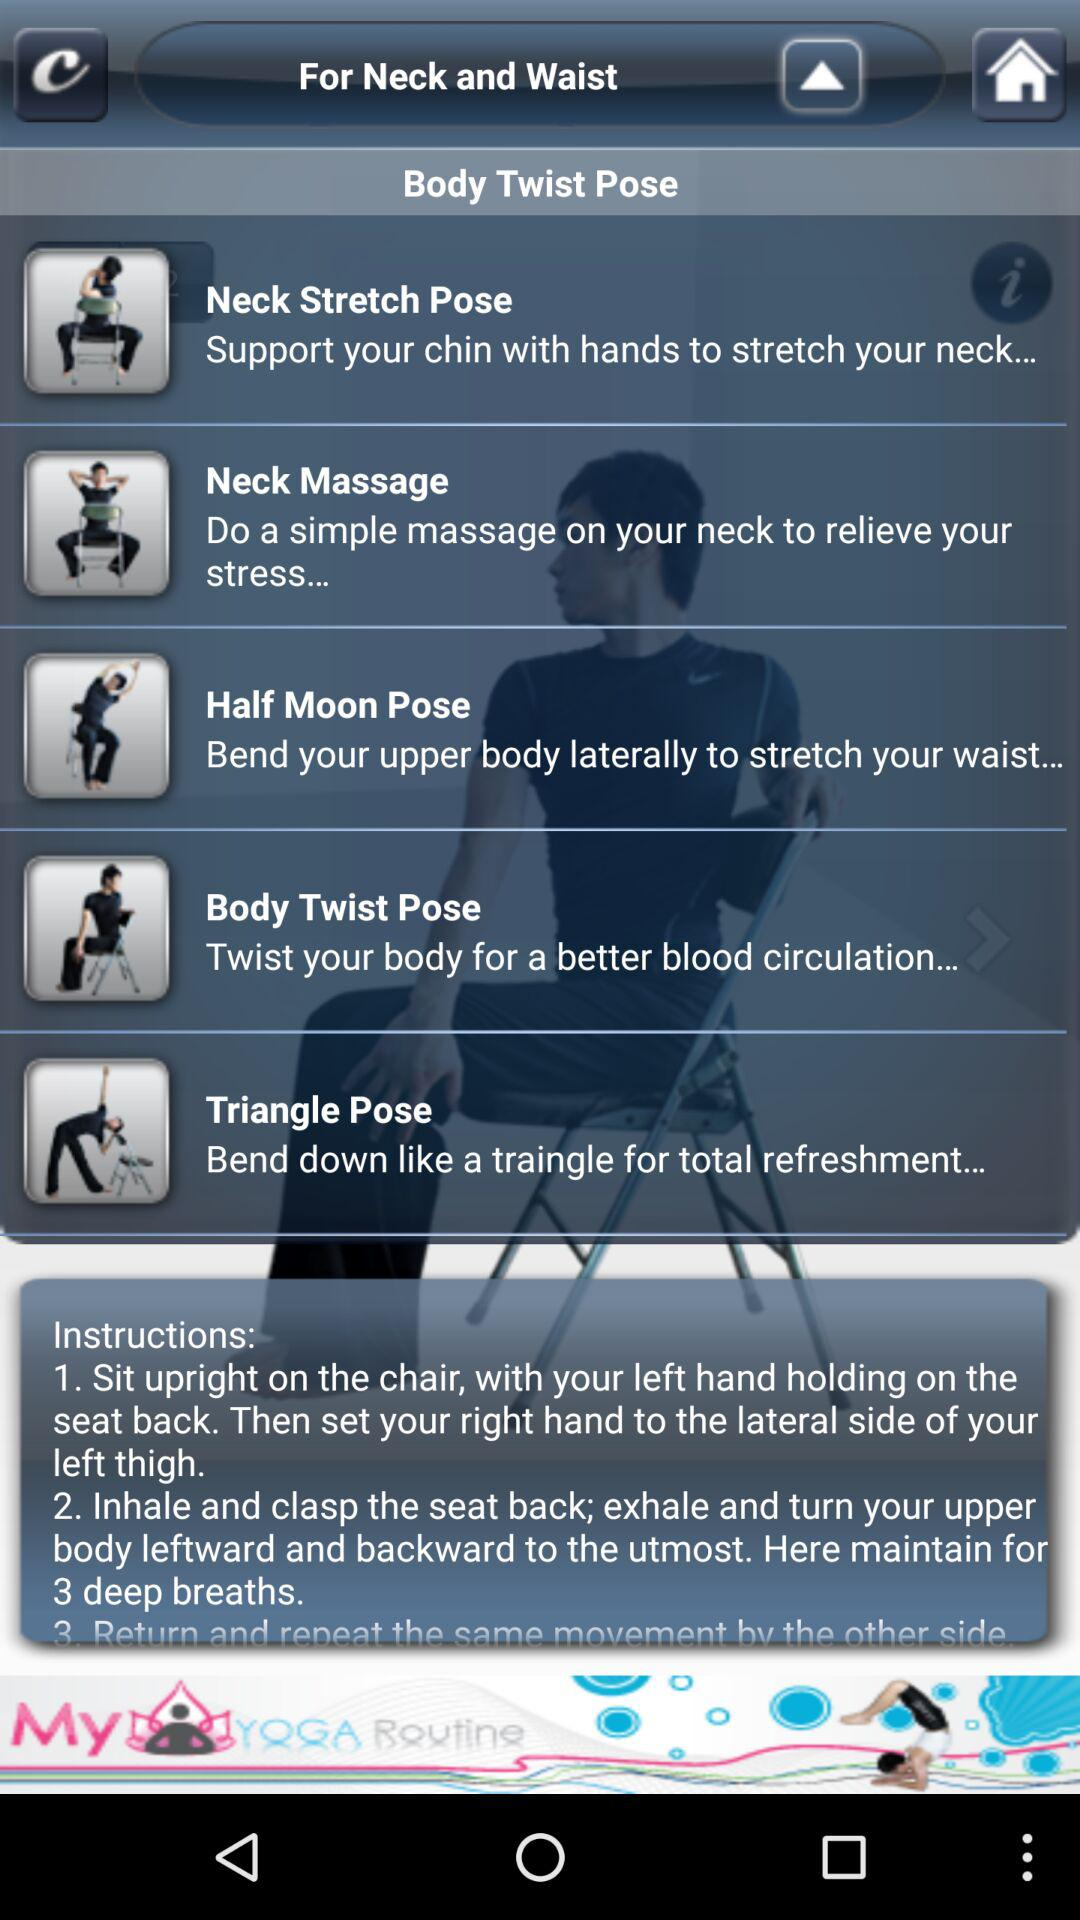Which pose is suitable for relieving your stress? The pose that is suitable for relieving your stress is "Neck Massage". 